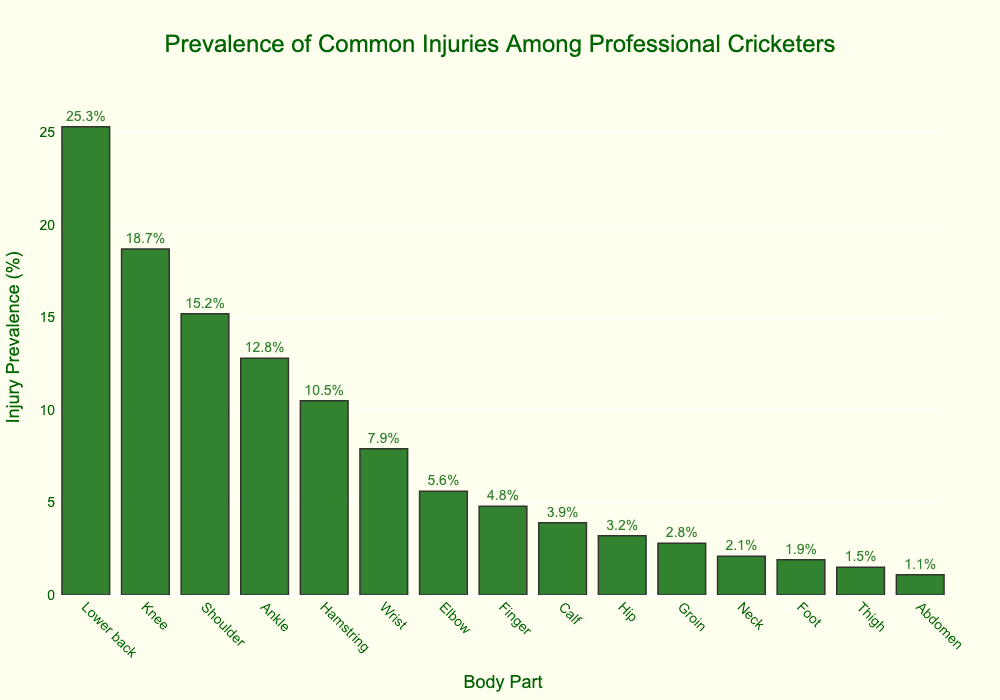Which body part has the highest injury prevalence among professional cricketers? The height of the bars represents the injury prevalence percentage for each body part. The tallest bar corresponds to the body part with the highest injury prevalence.
Answer: Lower back What is the difference in injury prevalence between the lower back and the knee? The injury prevalence for the lower back is 25.3%, and for the knee, it is 18.7%. Subtract the knee prevalence from the lower back prevalence: 25.3% - 18.7% = 6.6%.
Answer: 6.6% Which body part has the lowest injury prevalence? The height of the bars represents the injury prevalence percentage. The shortest bar corresponds to the body part with the lowest injury prevalence.
Answer: Abdomen How many body parts have an injury prevalence of more than 10%? Count the number of bars that have a height greater than 10% on the y-axis.
Answer: 5 Compare the injury prevalence between the shoulder and the ankle. Which one is higher, and by how much? The injury prevalence for the shoulder is 15.2%, and for the ankle, it is 12.8%. Subtract the ankle prevalence from the shoulder prevalence: 15.2% - 12.8% = 2.4%.
Answer: Shoulder by 2.4% What is the injury prevalence range from the highest to the lowest body part? The range is calculated by subtracting the lowest injury prevalence (abdomen: 1.1%) from the highest (lower back: 25.3%): 25.3% - 1.1% = 24.2%.
Answer: 24.2% Are there more body parts with an injury prevalence below 5% or above 5%? Count the number of bars with a height below 5% and those with a height above 5%. Compare these two counts.
Answer: Below 5% What is the combined injury prevalence of the elbow and the wrist? The injury prevalence for the elbow is 5.6%, and for the wrist, it is 7.9%. Add these two prevalence rates: 5.6% + 7.9% = 13.5%.
Answer: 13.5% What is the average injury prevalence of the hamstring, calf, and hip? Sum the prevalence rates for the hamstring (10.5%), calf (3.9%), and hip (3.2%). Then divide by the number of body parts (3): (10.5% + 3.9% + 3.2%) / 3 = 17.6% / 3 ≈ 5.87%.
Answer: 5.87% Which body parts have an injury prevalence between 10% and 20%? Identify the bars with heights between 10% and 20% on the y-axis.
Answer: Knee, Shoulder, Ankle, Hamstring 